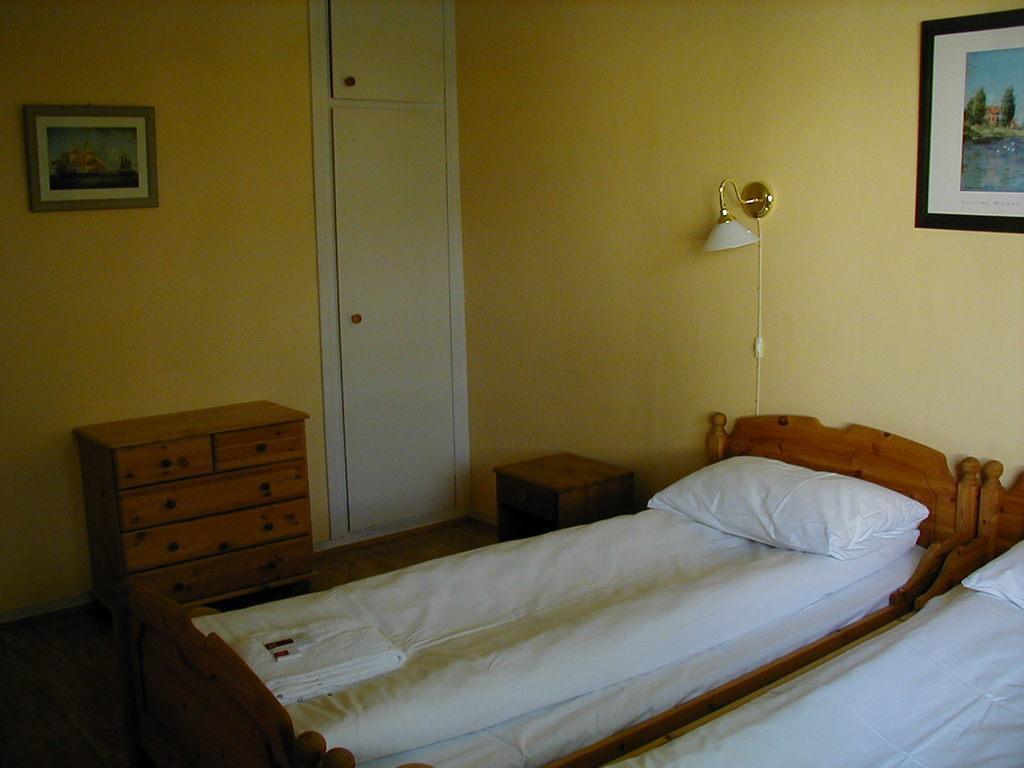Describe this image in one or two sentences. As we can see in the image there a yellow color wall, photo frame, lamp and two beds. 